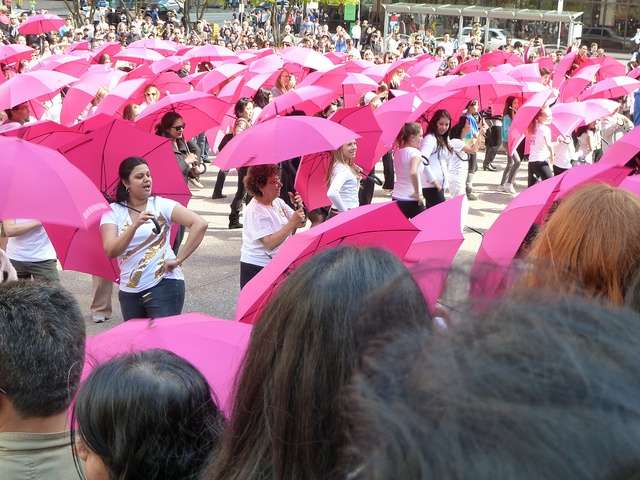Describe the objects in this image and their specific colors. I can see people in beige, gray, black, white, and darkblue tones, umbrella in beige, violet, lavender, and gray tones, people in beige, black, gray, and brown tones, people in beige, brown, and maroon tones, and people in beige, lavender, brown, black, and tan tones in this image. 